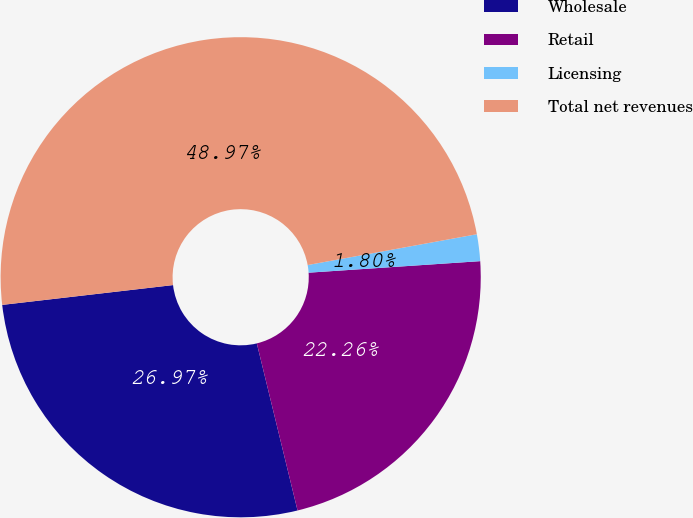Convert chart. <chart><loc_0><loc_0><loc_500><loc_500><pie_chart><fcel>Wholesale<fcel>Retail<fcel>Licensing<fcel>Total net revenues<nl><fcel>26.97%<fcel>22.26%<fcel>1.8%<fcel>48.97%<nl></chart> 